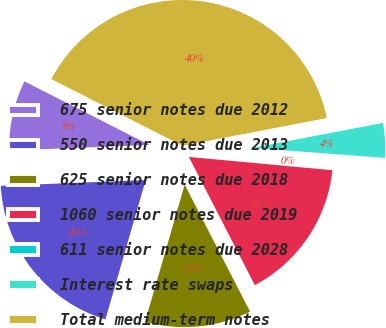Convert chart. <chart><loc_0><loc_0><loc_500><loc_500><pie_chart><fcel>675 senior notes due 2012<fcel>550 senior notes due 2013<fcel>625 senior notes due 2018<fcel>1060 senior notes due 2019<fcel>611 senior notes due 2028<fcel>Interest rate swaps<fcel>Total medium-term notes<nl><fcel>8.12%<fcel>19.89%<fcel>12.04%<fcel>15.97%<fcel>0.28%<fcel>4.2%<fcel>39.5%<nl></chart> 